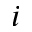<formula> <loc_0><loc_0><loc_500><loc_500>i</formula> 